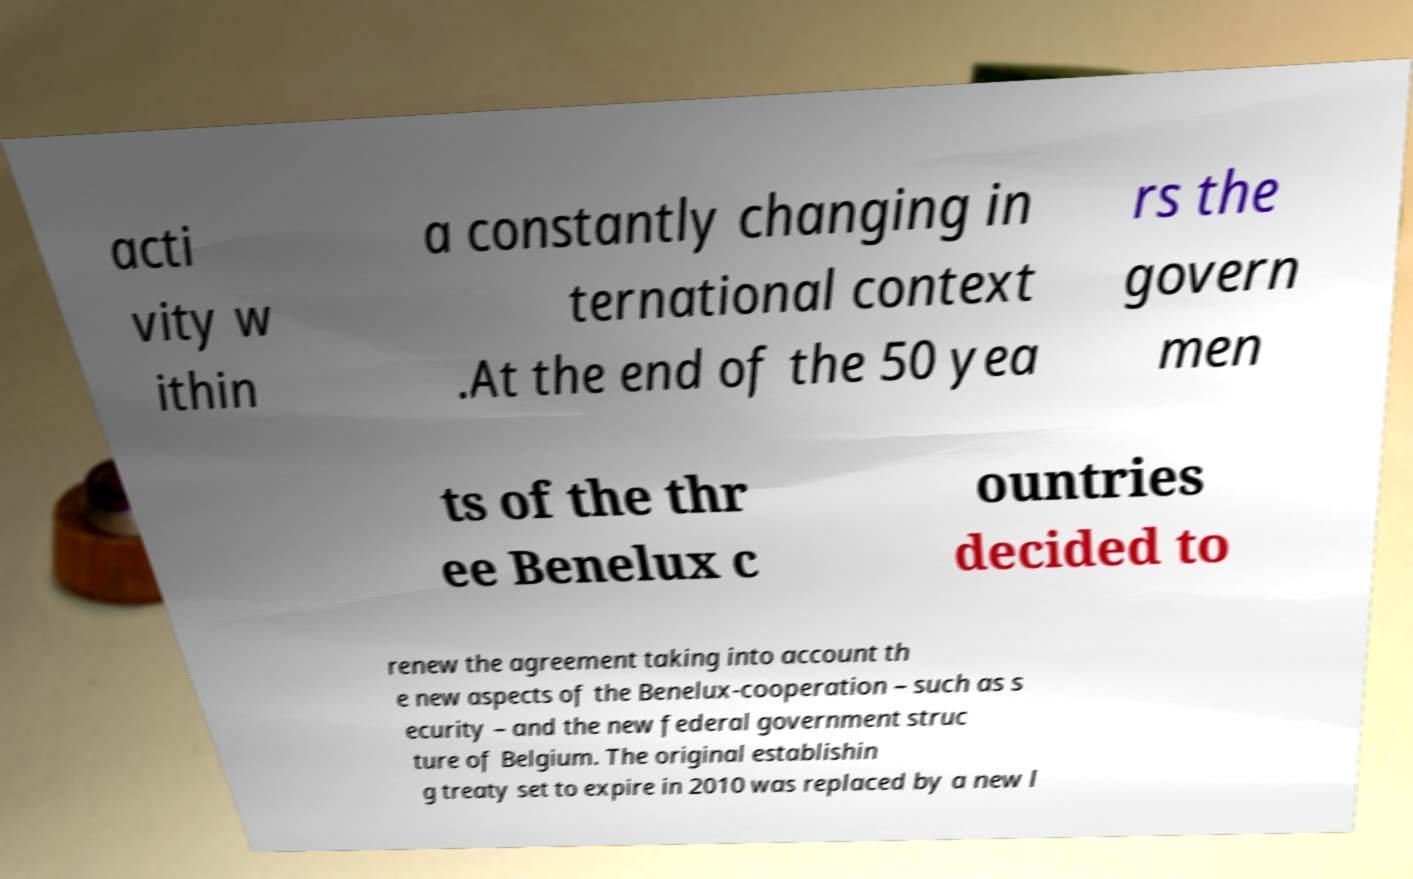What messages or text are displayed in this image? I need them in a readable, typed format. acti vity w ithin a constantly changing in ternational context .At the end of the 50 yea rs the govern men ts of the thr ee Benelux c ountries decided to renew the agreement taking into account th e new aspects of the Benelux-cooperation – such as s ecurity – and the new federal government struc ture of Belgium. The original establishin g treaty set to expire in 2010 was replaced by a new l 